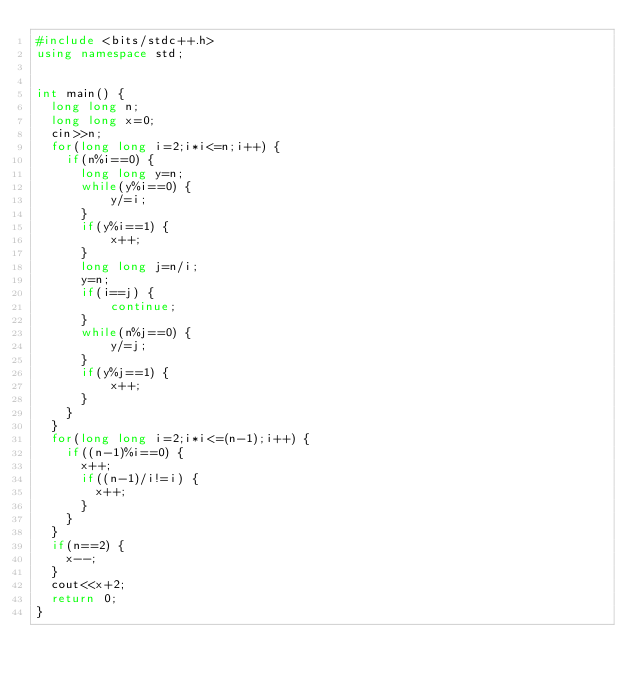Convert code to text. <code><loc_0><loc_0><loc_500><loc_500><_C++_>#include <bits/stdc++.h>
using namespace std;
 
 
int main() {
  long long n;
  long long x=0;
  cin>>n;
  for(long long i=2;i*i<=n;i++) {
    if(n%i==0) {
    	long long y=n;
    	while(y%i==0) {
      		y/=i;
    	}
    	if(y%i==1) {
      		x++;
    	}
   		long long j=n/i;
    	y=n;
    	if(i==j) {
      		continue;
    	}
    	while(n%j==0) {
      		y/=j;
    	}
    	if(y%j==1) {
      		x++;
    	}
  	}
  }
  for(long long i=2;i*i<=(n-1);i++) {
    if((n-1)%i==0) {
      x++;
      if((n-1)/i!=i) {
        x++;
      }
    }
  }
  if(n==2) {
    x--;
  }
  cout<<x+2;
  return 0;
}</code> 